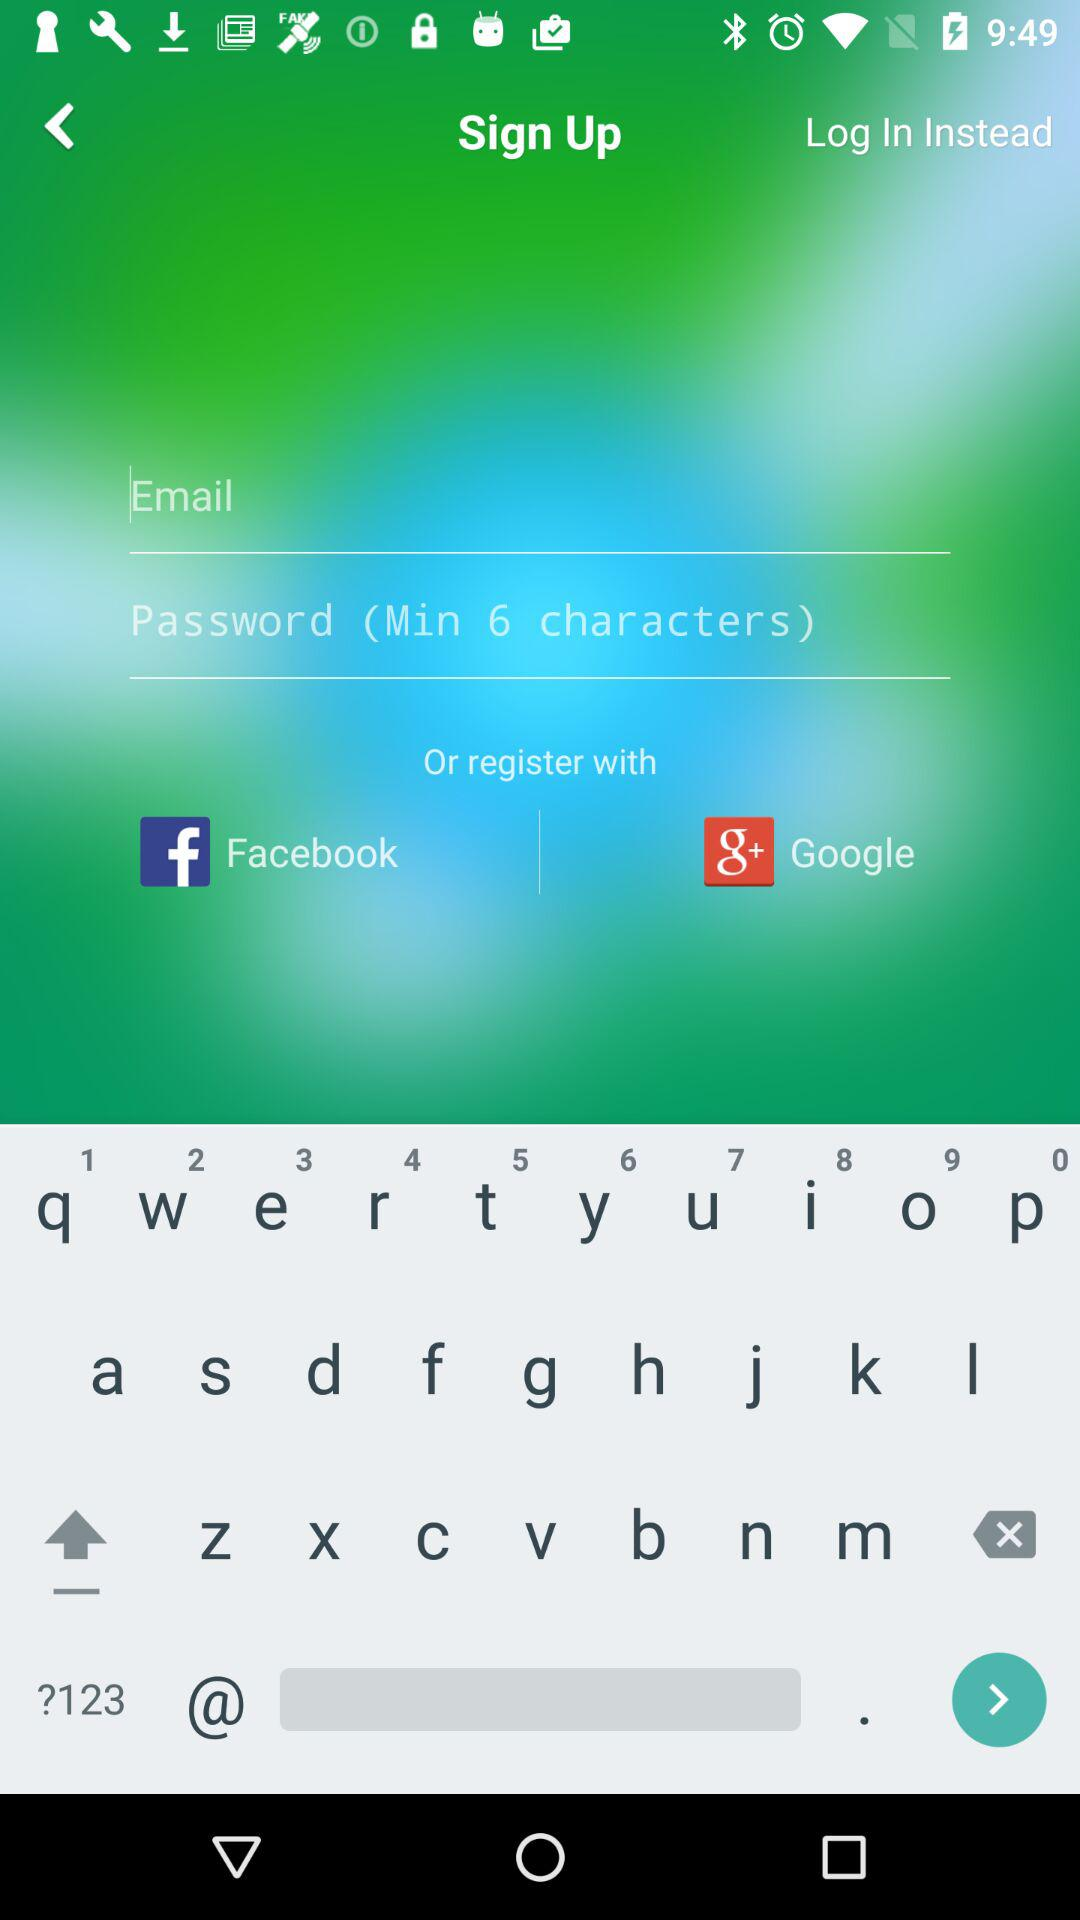Through what application can the user log in? The user can log in through "Facebook". 